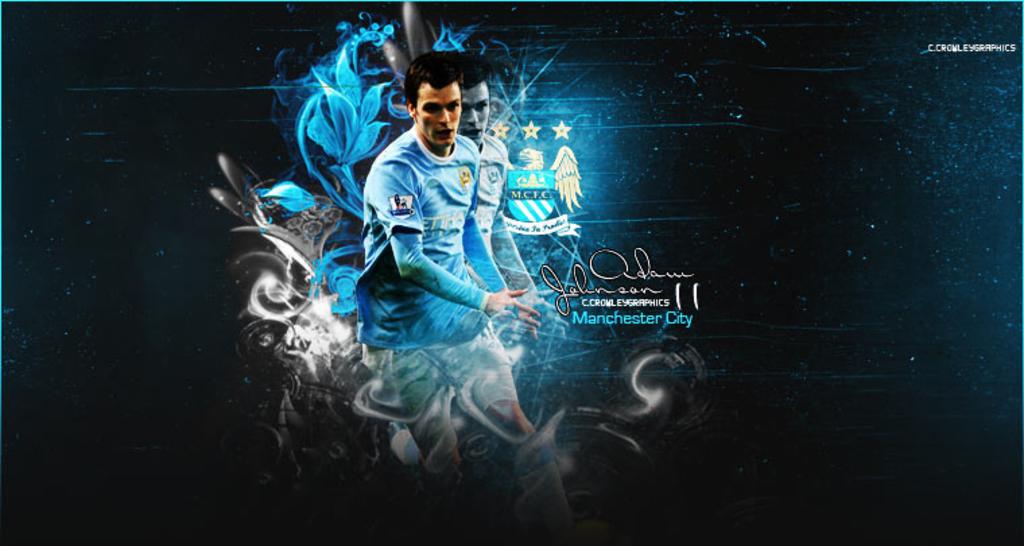What team does he play for?
Your answer should be very brief. Manchester city. 